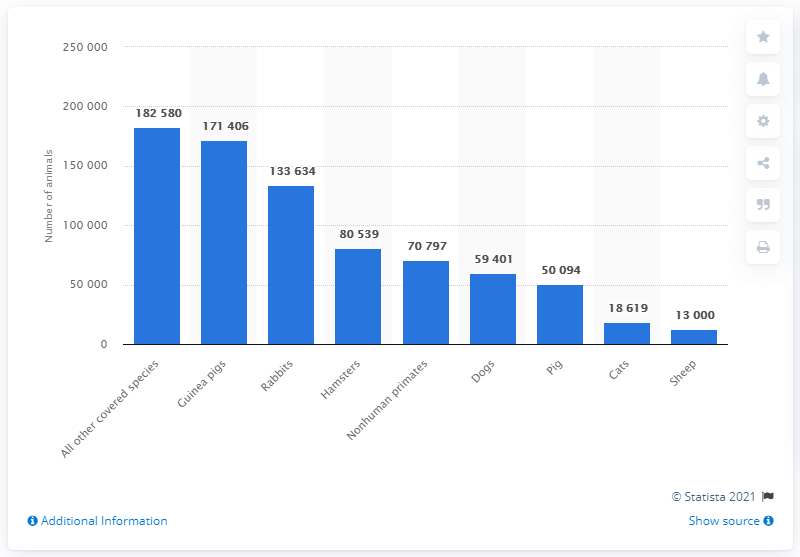Indicate a few pertinent items in this graphic. In 2018, a total of 171,406 guinea pigs were used in research facilities in the United States. 